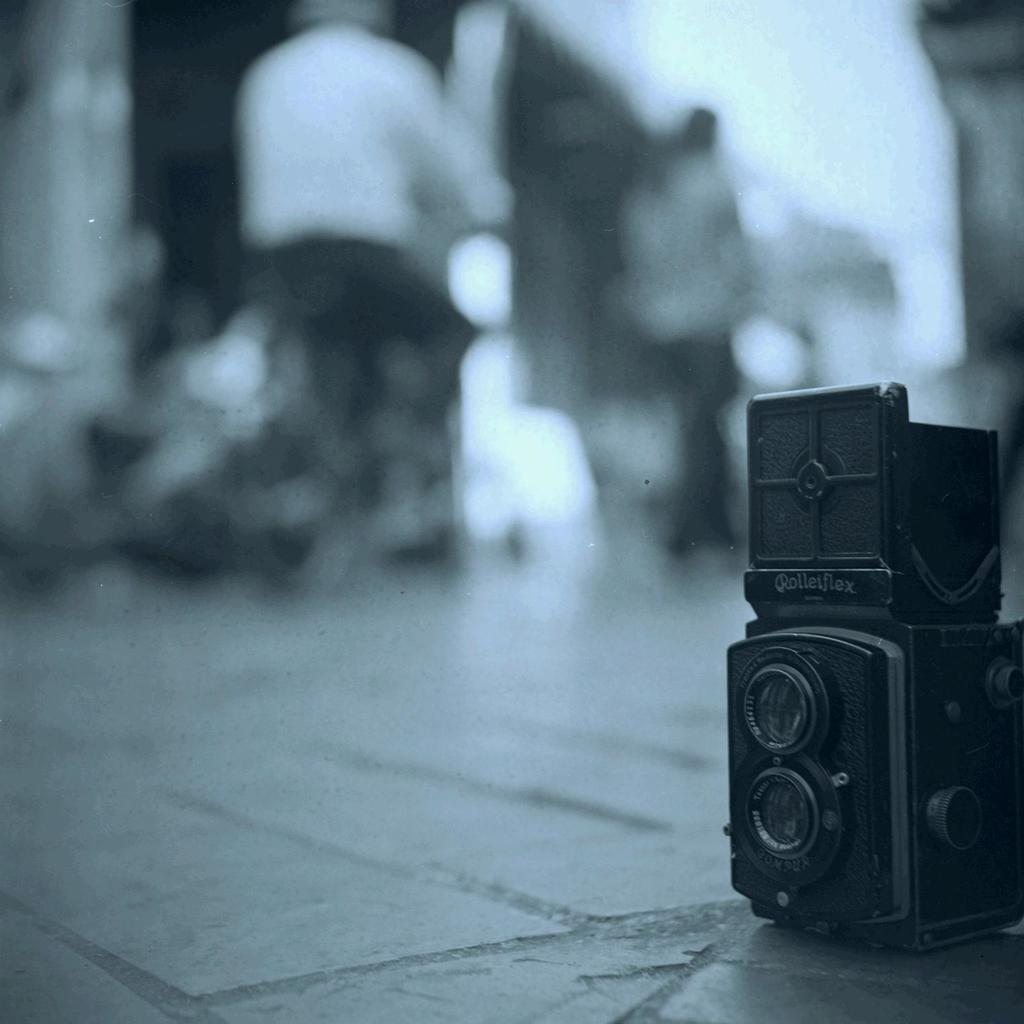What object is on the ground in the image? There is a camera on the ground in the image. How many people are in the image? There are two persons in the image. What can be observed about the background of the image? The background of the image is blurred. What color scheme is used in the image? The image is in black and white mode. What type of furniture is visible in the image? There is no furniture present in the image. What substance is being heated by the persons in the image? There is no substance being heated in the image; the two persons are not engaged in any activity involving heat. 